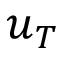<formula> <loc_0><loc_0><loc_500><loc_500>u _ { T }</formula> 